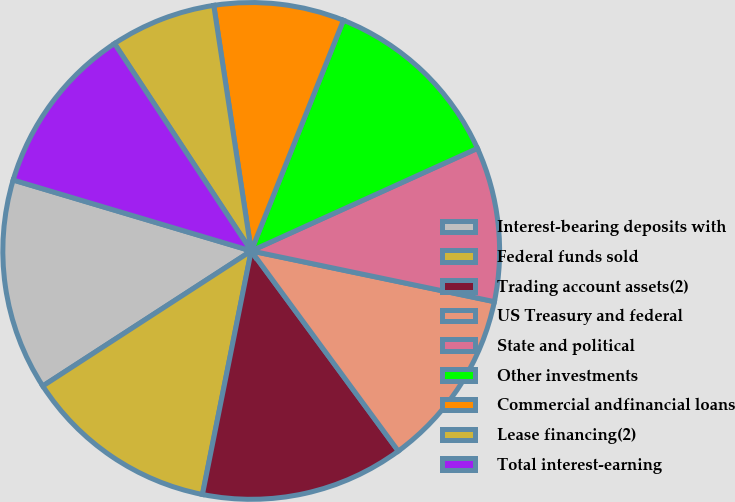<chart> <loc_0><loc_0><loc_500><loc_500><pie_chart><fcel>Interest-bearing deposits with<fcel>Federal funds sold<fcel>Trading account assets(2)<fcel>US Treasury and federal<fcel>State and political<fcel>Other investments<fcel>Commercial andfinancial loans<fcel>Lease financing(2)<fcel>Total interest-earning<nl><fcel>13.76%<fcel>12.7%<fcel>13.23%<fcel>11.64%<fcel>10.05%<fcel>12.17%<fcel>8.46%<fcel>6.87%<fcel>11.11%<nl></chart> 